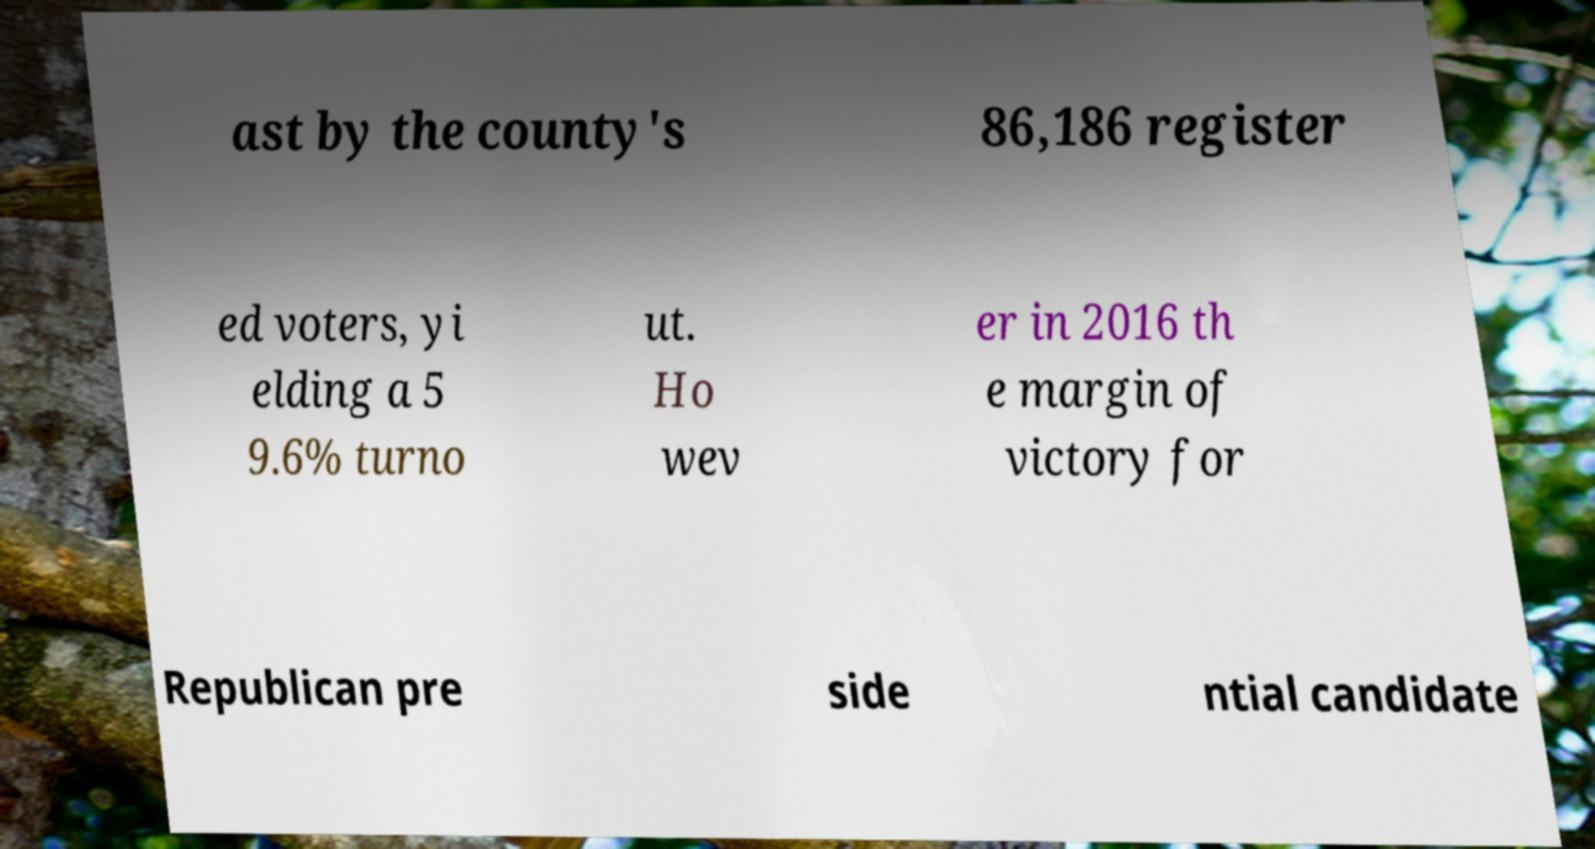What messages or text are displayed in this image? I need them in a readable, typed format. ast by the county's 86,186 register ed voters, yi elding a 5 9.6% turno ut. Ho wev er in 2016 th e margin of victory for Republican pre side ntial candidate 